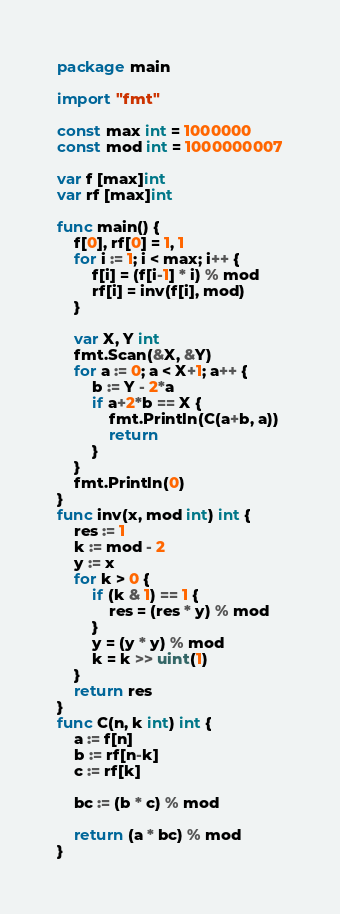Convert code to text. <code><loc_0><loc_0><loc_500><loc_500><_Go_>package main

import "fmt"

const max int = 1000000
const mod int = 1000000007

var f [max]int
var rf [max]int

func main() {
	f[0], rf[0] = 1, 1
	for i := 1; i < max; i++ {
		f[i] = (f[i-1] * i) % mod
		rf[i] = inv(f[i], mod)
	}

	var X, Y int
	fmt.Scan(&X, &Y)
	for a := 0; a < X+1; a++ {
		b := Y - 2*a
		if a+2*b == X {
			fmt.Println(C(a+b, a))
			return
		}
	}
	fmt.Println(0)
}
func inv(x, mod int) int {
	res := 1
	k := mod - 2
	y := x
	for k > 0 {
		if (k & 1) == 1 {
			res = (res * y) % mod
		}
		y = (y * y) % mod
		k = k >> uint(1)
	}
	return res
}
func C(n, k int) int {
	a := f[n]
	b := rf[n-k]
	c := rf[k]

	bc := (b * c) % mod

	return (a * bc) % mod
}
</code> 